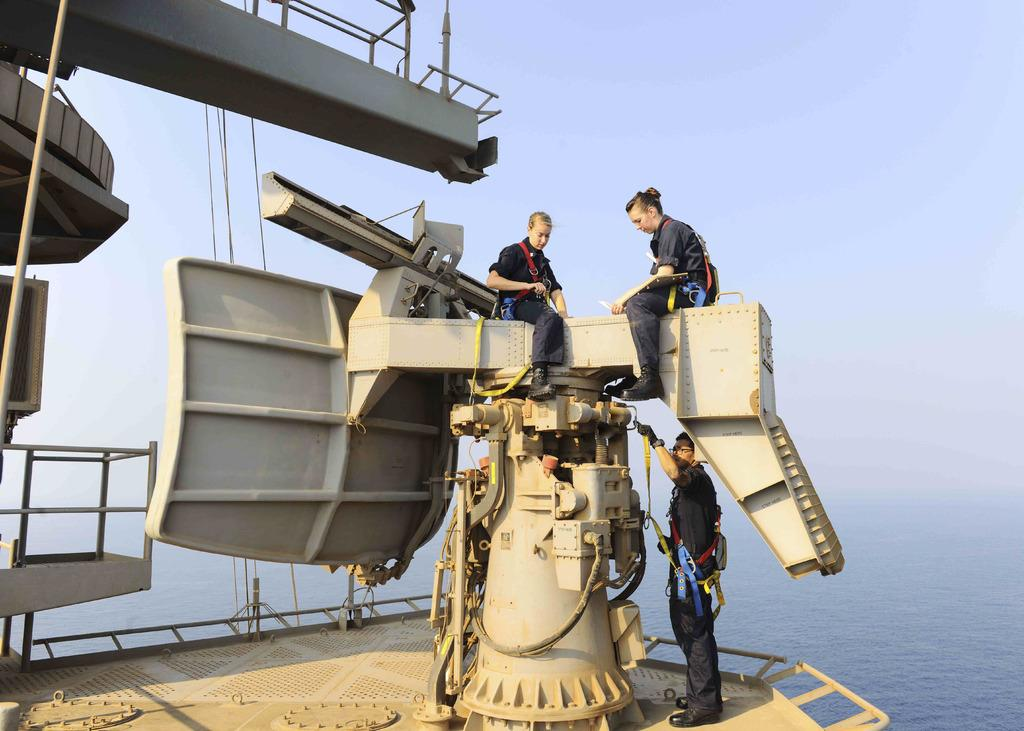What are the women doing in the image? The two women are sitting on a metal object in the image. What is the man doing in the image? The man is standing on a platform in the image. Can you describe the metal object on the left side of the image? There is a metal object on the left side of the image, but its specific details are not mentioned in the facts. What can be seen in the background of the image? Water and the sky are visible in the background of the image. How many legs does the fiction have in the image? There is no fiction present in the image, so it is not possible to determine the number of legs it might have. 